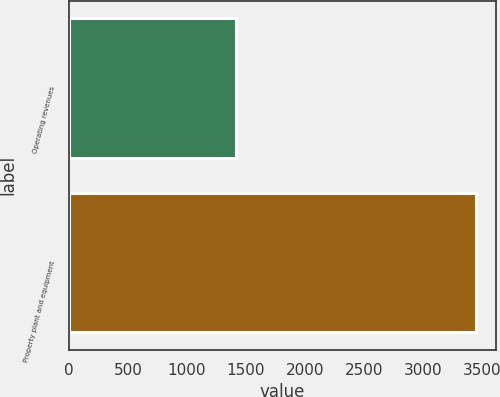Convert chart to OTSL. <chart><loc_0><loc_0><loc_500><loc_500><bar_chart><fcel>Operating revenues<fcel>Property plant and equipment<nl><fcel>1416<fcel>3447<nl></chart> 